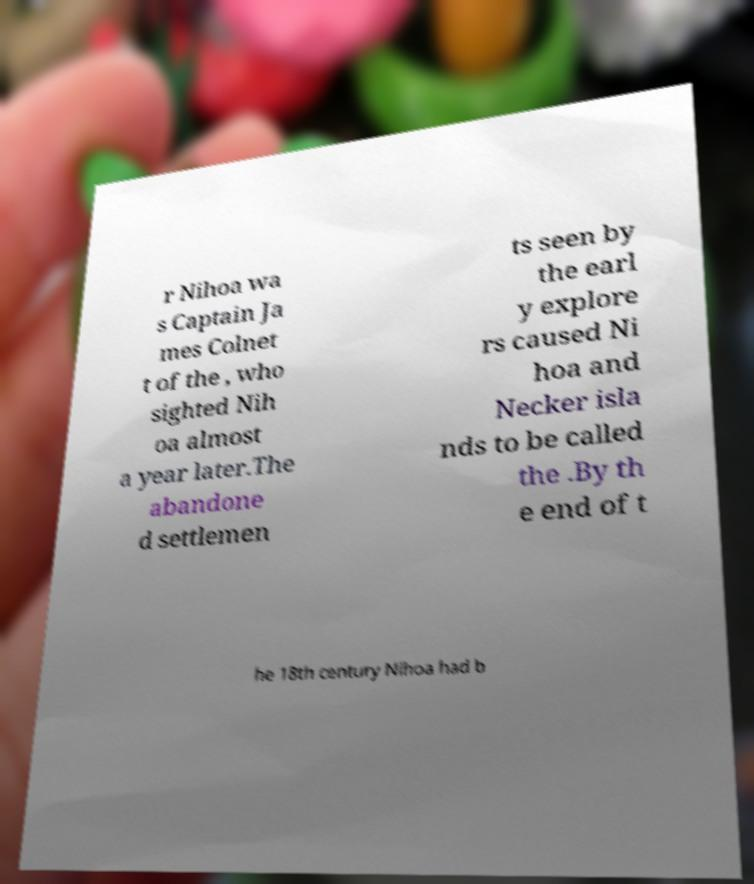There's text embedded in this image that I need extracted. Can you transcribe it verbatim? r Nihoa wa s Captain Ja mes Colnet t of the , who sighted Nih oa almost a year later.The abandone d settlemen ts seen by the earl y explore rs caused Ni hoa and Necker isla nds to be called the .By th e end of t he 18th century Nihoa had b 